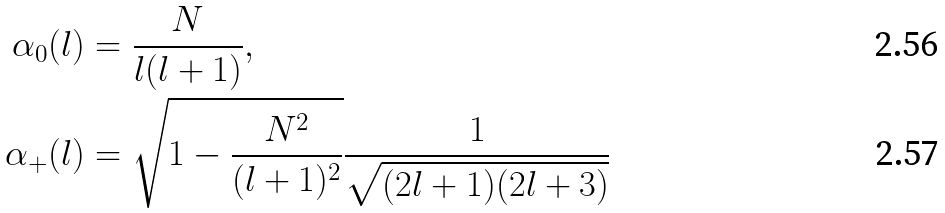<formula> <loc_0><loc_0><loc_500><loc_500>\alpha _ { 0 } ( l ) & = \frac { N } { l ( l + 1 ) } , \\ \alpha _ { + } ( l ) & = \sqrt { 1 - \frac { N ^ { 2 } } { ( l + 1 ) ^ { 2 } } } \frac { 1 } { \sqrt { ( 2 l + 1 ) ( 2 l + 3 ) } }</formula> 